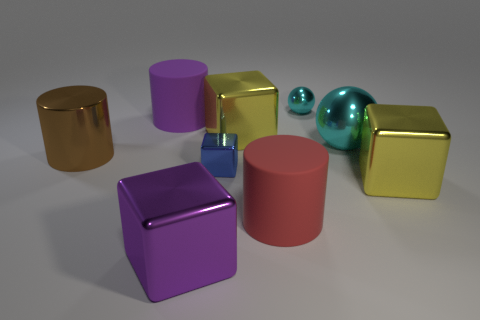Subtract all tiny blue shiny blocks. How many blocks are left? 3 Subtract all purple cubes. How many cubes are left? 3 Subtract 1 cubes. How many cubes are left? 3 Subtract all brown spheres. Subtract all blue blocks. How many spheres are left? 2 Subtract all yellow spheres. How many green cylinders are left? 0 Subtract all small red cylinders. Subtract all metal balls. How many objects are left? 7 Add 2 big cylinders. How many big cylinders are left? 5 Add 6 large shiny blocks. How many large shiny blocks exist? 9 Subtract 1 cyan spheres. How many objects are left? 8 Subtract all spheres. How many objects are left? 7 